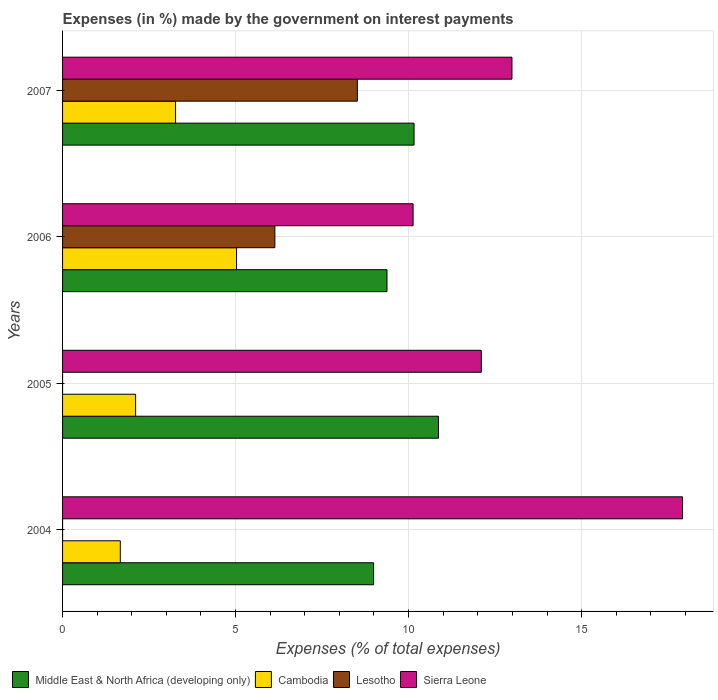How many different coloured bars are there?
Provide a short and direct response. 4. Are the number of bars per tick equal to the number of legend labels?
Provide a short and direct response. Yes. How many bars are there on the 4th tick from the top?
Provide a short and direct response. 4. How many bars are there on the 3rd tick from the bottom?
Your answer should be very brief. 4. In how many cases, is the number of bars for a given year not equal to the number of legend labels?
Keep it short and to the point. 0. What is the percentage of expenses made by the government on interest payments in Lesotho in 2007?
Make the answer very short. 8.52. Across all years, what is the maximum percentage of expenses made by the government on interest payments in Middle East & North Africa (developing only)?
Your answer should be compact. 10.86. Across all years, what is the minimum percentage of expenses made by the government on interest payments in Sierra Leone?
Your answer should be very brief. 10.13. In which year was the percentage of expenses made by the government on interest payments in Lesotho maximum?
Provide a short and direct response. 2007. What is the total percentage of expenses made by the government on interest payments in Sierra Leone in the graph?
Provide a short and direct response. 53.13. What is the difference between the percentage of expenses made by the government on interest payments in Middle East & North Africa (developing only) in 2004 and that in 2005?
Provide a succinct answer. -1.87. What is the difference between the percentage of expenses made by the government on interest payments in Lesotho in 2004 and the percentage of expenses made by the government on interest payments in Sierra Leone in 2006?
Make the answer very short. -10.13. What is the average percentage of expenses made by the government on interest payments in Sierra Leone per year?
Make the answer very short. 13.28. In the year 2006, what is the difference between the percentage of expenses made by the government on interest payments in Cambodia and percentage of expenses made by the government on interest payments in Middle East & North Africa (developing only)?
Your answer should be compact. -4.35. In how many years, is the percentage of expenses made by the government on interest payments in Lesotho greater than 14 %?
Make the answer very short. 0. What is the ratio of the percentage of expenses made by the government on interest payments in Cambodia in 2005 to that in 2006?
Your answer should be compact. 0.42. Is the difference between the percentage of expenses made by the government on interest payments in Cambodia in 2004 and 2005 greater than the difference between the percentage of expenses made by the government on interest payments in Middle East & North Africa (developing only) in 2004 and 2005?
Make the answer very short. Yes. What is the difference between the highest and the second highest percentage of expenses made by the government on interest payments in Cambodia?
Your answer should be compact. 1.76. What is the difference between the highest and the lowest percentage of expenses made by the government on interest payments in Sierra Leone?
Give a very brief answer. 7.79. In how many years, is the percentage of expenses made by the government on interest payments in Lesotho greater than the average percentage of expenses made by the government on interest payments in Lesotho taken over all years?
Your answer should be compact. 2. Is the sum of the percentage of expenses made by the government on interest payments in Sierra Leone in 2004 and 2007 greater than the maximum percentage of expenses made by the government on interest payments in Cambodia across all years?
Keep it short and to the point. Yes. Is it the case that in every year, the sum of the percentage of expenses made by the government on interest payments in Lesotho and percentage of expenses made by the government on interest payments in Sierra Leone is greater than the sum of percentage of expenses made by the government on interest payments in Cambodia and percentage of expenses made by the government on interest payments in Middle East & North Africa (developing only)?
Provide a short and direct response. No. What does the 3rd bar from the top in 2007 represents?
Your answer should be compact. Cambodia. What does the 1st bar from the bottom in 2007 represents?
Offer a terse response. Middle East & North Africa (developing only). Are all the bars in the graph horizontal?
Your response must be concise. Yes. What is the difference between two consecutive major ticks on the X-axis?
Make the answer very short. 5. Does the graph contain any zero values?
Keep it short and to the point. No. Does the graph contain grids?
Your answer should be compact. Yes. Where does the legend appear in the graph?
Ensure brevity in your answer.  Bottom left. How are the legend labels stacked?
Your answer should be compact. Horizontal. What is the title of the graph?
Ensure brevity in your answer.  Expenses (in %) made by the government on interest payments. What is the label or title of the X-axis?
Your answer should be compact. Expenses (% of total expenses). What is the Expenses (% of total expenses) of Middle East & North Africa (developing only) in 2004?
Your answer should be compact. 8.99. What is the Expenses (% of total expenses) in Cambodia in 2004?
Your answer should be very brief. 1.67. What is the Expenses (% of total expenses) of Lesotho in 2004?
Offer a very short reply. 2.999997087200831e-5. What is the Expenses (% of total expenses) of Sierra Leone in 2004?
Provide a short and direct response. 17.92. What is the Expenses (% of total expenses) in Middle East & North Africa (developing only) in 2005?
Provide a succinct answer. 10.86. What is the Expenses (% of total expenses) in Cambodia in 2005?
Offer a terse response. 2.11. What is the Expenses (% of total expenses) in Lesotho in 2005?
Your answer should be very brief. 0. What is the Expenses (% of total expenses) of Sierra Leone in 2005?
Offer a terse response. 12.1. What is the Expenses (% of total expenses) of Middle East & North Africa (developing only) in 2006?
Give a very brief answer. 9.38. What is the Expenses (% of total expenses) of Cambodia in 2006?
Your answer should be compact. 5.03. What is the Expenses (% of total expenses) of Lesotho in 2006?
Keep it short and to the point. 6.14. What is the Expenses (% of total expenses) of Sierra Leone in 2006?
Offer a terse response. 10.13. What is the Expenses (% of total expenses) in Middle East & North Africa (developing only) in 2007?
Your answer should be very brief. 10.16. What is the Expenses (% of total expenses) of Cambodia in 2007?
Keep it short and to the point. 3.27. What is the Expenses (% of total expenses) in Lesotho in 2007?
Provide a short and direct response. 8.52. What is the Expenses (% of total expenses) in Sierra Leone in 2007?
Offer a terse response. 12.99. Across all years, what is the maximum Expenses (% of total expenses) in Middle East & North Africa (developing only)?
Ensure brevity in your answer.  10.86. Across all years, what is the maximum Expenses (% of total expenses) in Cambodia?
Your answer should be compact. 5.03. Across all years, what is the maximum Expenses (% of total expenses) in Lesotho?
Ensure brevity in your answer.  8.52. Across all years, what is the maximum Expenses (% of total expenses) of Sierra Leone?
Provide a short and direct response. 17.92. Across all years, what is the minimum Expenses (% of total expenses) of Middle East & North Africa (developing only)?
Your answer should be compact. 8.99. Across all years, what is the minimum Expenses (% of total expenses) of Cambodia?
Ensure brevity in your answer.  1.67. Across all years, what is the minimum Expenses (% of total expenses) of Lesotho?
Provide a short and direct response. 2.999997087200831e-5. Across all years, what is the minimum Expenses (% of total expenses) of Sierra Leone?
Your answer should be very brief. 10.13. What is the total Expenses (% of total expenses) of Middle East & North Africa (developing only) in the graph?
Make the answer very short. 39.39. What is the total Expenses (% of total expenses) in Cambodia in the graph?
Provide a short and direct response. 12.08. What is the total Expenses (% of total expenses) in Lesotho in the graph?
Offer a very short reply. 14.65. What is the total Expenses (% of total expenses) of Sierra Leone in the graph?
Offer a terse response. 53.13. What is the difference between the Expenses (% of total expenses) of Middle East & North Africa (developing only) in 2004 and that in 2005?
Give a very brief answer. -1.87. What is the difference between the Expenses (% of total expenses) in Cambodia in 2004 and that in 2005?
Give a very brief answer. -0.44. What is the difference between the Expenses (% of total expenses) in Lesotho in 2004 and that in 2005?
Make the answer very short. -0. What is the difference between the Expenses (% of total expenses) of Sierra Leone in 2004 and that in 2005?
Offer a very short reply. 5.81. What is the difference between the Expenses (% of total expenses) in Middle East & North Africa (developing only) in 2004 and that in 2006?
Your answer should be compact. -0.39. What is the difference between the Expenses (% of total expenses) of Cambodia in 2004 and that in 2006?
Keep it short and to the point. -3.36. What is the difference between the Expenses (% of total expenses) of Lesotho in 2004 and that in 2006?
Offer a terse response. -6.14. What is the difference between the Expenses (% of total expenses) of Sierra Leone in 2004 and that in 2006?
Ensure brevity in your answer.  7.79. What is the difference between the Expenses (% of total expenses) of Middle East & North Africa (developing only) in 2004 and that in 2007?
Provide a succinct answer. -1.17. What is the difference between the Expenses (% of total expenses) in Cambodia in 2004 and that in 2007?
Offer a terse response. -1.6. What is the difference between the Expenses (% of total expenses) of Lesotho in 2004 and that in 2007?
Give a very brief answer. -8.52. What is the difference between the Expenses (% of total expenses) of Sierra Leone in 2004 and that in 2007?
Offer a very short reply. 4.93. What is the difference between the Expenses (% of total expenses) of Middle East & North Africa (developing only) in 2005 and that in 2006?
Offer a terse response. 1.49. What is the difference between the Expenses (% of total expenses) in Cambodia in 2005 and that in 2006?
Offer a very short reply. -2.92. What is the difference between the Expenses (% of total expenses) in Lesotho in 2005 and that in 2006?
Provide a succinct answer. -6.14. What is the difference between the Expenses (% of total expenses) of Sierra Leone in 2005 and that in 2006?
Ensure brevity in your answer.  1.97. What is the difference between the Expenses (% of total expenses) in Middle East & North Africa (developing only) in 2005 and that in 2007?
Your response must be concise. 0.71. What is the difference between the Expenses (% of total expenses) in Cambodia in 2005 and that in 2007?
Offer a terse response. -1.15. What is the difference between the Expenses (% of total expenses) in Lesotho in 2005 and that in 2007?
Keep it short and to the point. -8.52. What is the difference between the Expenses (% of total expenses) in Sierra Leone in 2005 and that in 2007?
Your answer should be very brief. -0.89. What is the difference between the Expenses (% of total expenses) of Middle East & North Africa (developing only) in 2006 and that in 2007?
Provide a succinct answer. -0.78. What is the difference between the Expenses (% of total expenses) of Cambodia in 2006 and that in 2007?
Ensure brevity in your answer.  1.76. What is the difference between the Expenses (% of total expenses) in Lesotho in 2006 and that in 2007?
Provide a short and direct response. -2.38. What is the difference between the Expenses (% of total expenses) of Sierra Leone in 2006 and that in 2007?
Your answer should be compact. -2.86. What is the difference between the Expenses (% of total expenses) of Middle East & North Africa (developing only) in 2004 and the Expenses (% of total expenses) of Cambodia in 2005?
Make the answer very short. 6.88. What is the difference between the Expenses (% of total expenses) in Middle East & North Africa (developing only) in 2004 and the Expenses (% of total expenses) in Lesotho in 2005?
Offer a very short reply. 8.99. What is the difference between the Expenses (% of total expenses) of Middle East & North Africa (developing only) in 2004 and the Expenses (% of total expenses) of Sierra Leone in 2005?
Offer a terse response. -3.11. What is the difference between the Expenses (% of total expenses) of Cambodia in 2004 and the Expenses (% of total expenses) of Lesotho in 2005?
Give a very brief answer. 1.67. What is the difference between the Expenses (% of total expenses) of Cambodia in 2004 and the Expenses (% of total expenses) of Sierra Leone in 2005?
Offer a very short reply. -10.43. What is the difference between the Expenses (% of total expenses) of Lesotho in 2004 and the Expenses (% of total expenses) of Sierra Leone in 2005?
Provide a short and direct response. -12.1. What is the difference between the Expenses (% of total expenses) in Middle East & North Africa (developing only) in 2004 and the Expenses (% of total expenses) in Cambodia in 2006?
Offer a very short reply. 3.96. What is the difference between the Expenses (% of total expenses) in Middle East & North Africa (developing only) in 2004 and the Expenses (% of total expenses) in Lesotho in 2006?
Provide a succinct answer. 2.85. What is the difference between the Expenses (% of total expenses) in Middle East & North Africa (developing only) in 2004 and the Expenses (% of total expenses) in Sierra Leone in 2006?
Offer a terse response. -1.14. What is the difference between the Expenses (% of total expenses) of Cambodia in 2004 and the Expenses (% of total expenses) of Lesotho in 2006?
Ensure brevity in your answer.  -4.47. What is the difference between the Expenses (% of total expenses) in Cambodia in 2004 and the Expenses (% of total expenses) in Sierra Leone in 2006?
Provide a succinct answer. -8.46. What is the difference between the Expenses (% of total expenses) in Lesotho in 2004 and the Expenses (% of total expenses) in Sierra Leone in 2006?
Your answer should be very brief. -10.13. What is the difference between the Expenses (% of total expenses) of Middle East & North Africa (developing only) in 2004 and the Expenses (% of total expenses) of Cambodia in 2007?
Provide a succinct answer. 5.72. What is the difference between the Expenses (% of total expenses) of Middle East & North Africa (developing only) in 2004 and the Expenses (% of total expenses) of Lesotho in 2007?
Offer a terse response. 0.47. What is the difference between the Expenses (% of total expenses) in Middle East & North Africa (developing only) in 2004 and the Expenses (% of total expenses) in Sierra Leone in 2007?
Your response must be concise. -4. What is the difference between the Expenses (% of total expenses) in Cambodia in 2004 and the Expenses (% of total expenses) in Lesotho in 2007?
Keep it short and to the point. -6.85. What is the difference between the Expenses (% of total expenses) of Cambodia in 2004 and the Expenses (% of total expenses) of Sierra Leone in 2007?
Provide a succinct answer. -11.32. What is the difference between the Expenses (% of total expenses) in Lesotho in 2004 and the Expenses (% of total expenses) in Sierra Leone in 2007?
Your answer should be compact. -12.99. What is the difference between the Expenses (% of total expenses) in Middle East & North Africa (developing only) in 2005 and the Expenses (% of total expenses) in Cambodia in 2006?
Make the answer very short. 5.84. What is the difference between the Expenses (% of total expenses) of Middle East & North Africa (developing only) in 2005 and the Expenses (% of total expenses) of Lesotho in 2006?
Ensure brevity in your answer.  4.73. What is the difference between the Expenses (% of total expenses) in Middle East & North Africa (developing only) in 2005 and the Expenses (% of total expenses) in Sierra Leone in 2006?
Your answer should be compact. 0.73. What is the difference between the Expenses (% of total expenses) of Cambodia in 2005 and the Expenses (% of total expenses) of Lesotho in 2006?
Keep it short and to the point. -4.02. What is the difference between the Expenses (% of total expenses) in Cambodia in 2005 and the Expenses (% of total expenses) in Sierra Leone in 2006?
Offer a very short reply. -8.02. What is the difference between the Expenses (% of total expenses) in Lesotho in 2005 and the Expenses (% of total expenses) in Sierra Leone in 2006?
Your answer should be compact. -10.13. What is the difference between the Expenses (% of total expenses) in Middle East & North Africa (developing only) in 2005 and the Expenses (% of total expenses) in Cambodia in 2007?
Offer a very short reply. 7.6. What is the difference between the Expenses (% of total expenses) in Middle East & North Africa (developing only) in 2005 and the Expenses (% of total expenses) in Lesotho in 2007?
Ensure brevity in your answer.  2.34. What is the difference between the Expenses (% of total expenses) in Middle East & North Africa (developing only) in 2005 and the Expenses (% of total expenses) in Sierra Leone in 2007?
Keep it short and to the point. -2.12. What is the difference between the Expenses (% of total expenses) in Cambodia in 2005 and the Expenses (% of total expenses) in Lesotho in 2007?
Your response must be concise. -6.41. What is the difference between the Expenses (% of total expenses) in Cambodia in 2005 and the Expenses (% of total expenses) in Sierra Leone in 2007?
Provide a short and direct response. -10.88. What is the difference between the Expenses (% of total expenses) of Lesotho in 2005 and the Expenses (% of total expenses) of Sierra Leone in 2007?
Offer a very short reply. -12.99. What is the difference between the Expenses (% of total expenses) in Middle East & North Africa (developing only) in 2006 and the Expenses (% of total expenses) in Cambodia in 2007?
Ensure brevity in your answer.  6.11. What is the difference between the Expenses (% of total expenses) of Middle East & North Africa (developing only) in 2006 and the Expenses (% of total expenses) of Lesotho in 2007?
Provide a succinct answer. 0.86. What is the difference between the Expenses (% of total expenses) of Middle East & North Africa (developing only) in 2006 and the Expenses (% of total expenses) of Sierra Leone in 2007?
Offer a very short reply. -3.61. What is the difference between the Expenses (% of total expenses) in Cambodia in 2006 and the Expenses (% of total expenses) in Lesotho in 2007?
Your response must be concise. -3.49. What is the difference between the Expenses (% of total expenses) of Cambodia in 2006 and the Expenses (% of total expenses) of Sierra Leone in 2007?
Your answer should be compact. -7.96. What is the difference between the Expenses (% of total expenses) of Lesotho in 2006 and the Expenses (% of total expenses) of Sierra Leone in 2007?
Make the answer very short. -6.85. What is the average Expenses (% of total expenses) in Middle East & North Africa (developing only) per year?
Your response must be concise. 9.85. What is the average Expenses (% of total expenses) in Cambodia per year?
Your response must be concise. 3.02. What is the average Expenses (% of total expenses) of Lesotho per year?
Provide a succinct answer. 3.66. What is the average Expenses (% of total expenses) in Sierra Leone per year?
Ensure brevity in your answer.  13.28. In the year 2004, what is the difference between the Expenses (% of total expenses) of Middle East & North Africa (developing only) and Expenses (% of total expenses) of Cambodia?
Your response must be concise. 7.32. In the year 2004, what is the difference between the Expenses (% of total expenses) in Middle East & North Africa (developing only) and Expenses (% of total expenses) in Lesotho?
Offer a terse response. 8.99. In the year 2004, what is the difference between the Expenses (% of total expenses) of Middle East & North Africa (developing only) and Expenses (% of total expenses) of Sierra Leone?
Your answer should be compact. -8.93. In the year 2004, what is the difference between the Expenses (% of total expenses) in Cambodia and Expenses (% of total expenses) in Lesotho?
Your answer should be very brief. 1.67. In the year 2004, what is the difference between the Expenses (% of total expenses) of Cambodia and Expenses (% of total expenses) of Sierra Leone?
Provide a succinct answer. -16.25. In the year 2004, what is the difference between the Expenses (% of total expenses) of Lesotho and Expenses (% of total expenses) of Sierra Leone?
Offer a terse response. -17.92. In the year 2005, what is the difference between the Expenses (% of total expenses) in Middle East & North Africa (developing only) and Expenses (% of total expenses) in Cambodia?
Offer a terse response. 8.75. In the year 2005, what is the difference between the Expenses (% of total expenses) in Middle East & North Africa (developing only) and Expenses (% of total expenses) in Lesotho?
Your answer should be compact. 10.86. In the year 2005, what is the difference between the Expenses (% of total expenses) of Middle East & North Africa (developing only) and Expenses (% of total expenses) of Sierra Leone?
Make the answer very short. -1.24. In the year 2005, what is the difference between the Expenses (% of total expenses) in Cambodia and Expenses (% of total expenses) in Lesotho?
Keep it short and to the point. 2.11. In the year 2005, what is the difference between the Expenses (% of total expenses) of Cambodia and Expenses (% of total expenses) of Sierra Leone?
Provide a succinct answer. -9.99. In the year 2005, what is the difference between the Expenses (% of total expenses) in Lesotho and Expenses (% of total expenses) in Sierra Leone?
Ensure brevity in your answer.  -12.1. In the year 2006, what is the difference between the Expenses (% of total expenses) of Middle East & North Africa (developing only) and Expenses (% of total expenses) of Cambodia?
Offer a terse response. 4.35. In the year 2006, what is the difference between the Expenses (% of total expenses) of Middle East & North Africa (developing only) and Expenses (% of total expenses) of Lesotho?
Provide a short and direct response. 3.24. In the year 2006, what is the difference between the Expenses (% of total expenses) in Middle East & North Africa (developing only) and Expenses (% of total expenses) in Sierra Leone?
Keep it short and to the point. -0.75. In the year 2006, what is the difference between the Expenses (% of total expenses) in Cambodia and Expenses (% of total expenses) in Lesotho?
Offer a very short reply. -1.11. In the year 2006, what is the difference between the Expenses (% of total expenses) of Cambodia and Expenses (% of total expenses) of Sierra Leone?
Make the answer very short. -5.1. In the year 2006, what is the difference between the Expenses (% of total expenses) of Lesotho and Expenses (% of total expenses) of Sierra Leone?
Provide a succinct answer. -3.99. In the year 2007, what is the difference between the Expenses (% of total expenses) in Middle East & North Africa (developing only) and Expenses (% of total expenses) in Cambodia?
Offer a very short reply. 6.89. In the year 2007, what is the difference between the Expenses (% of total expenses) of Middle East & North Africa (developing only) and Expenses (% of total expenses) of Lesotho?
Give a very brief answer. 1.64. In the year 2007, what is the difference between the Expenses (% of total expenses) in Middle East & North Africa (developing only) and Expenses (% of total expenses) in Sierra Leone?
Your response must be concise. -2.83. In the year 2007, what is the difference between the Expenses (% of total expenses) of Cambodia and Expenses (% of total expenses) of Lesotho?
Your answer should be compact. -5.25. In the year 2007, what is the difference between the Expenses (% of total expenses) of Cambodia and Expenses (% of total expenses) of Sierra Leone?
Offer a terse response. -9.72. In the year 2007, what is the difference between the Expenses (% of total expenses) in Lesotho and Expenses (% of total expenses) in Sierra Leone?
Provide a short and direct response. -4.47. What is the ratio of the Expenses (% of total expenses) in Middle East & North Africa (developing only) in 2004 to that in 2005?
Your answer should be compact. 0.83. What is the ratio of the Expenses (% of total expenses) of Cambodia in 2004 to that in 2005?
Provide a short and direct response. 0.79. What is the ratio of the Expenses (% of total expenses) of Lesotho in 2004 to that in 2005?
Your answer should be very brief. 0.3. What is the ratio of the Expenses (% of total expenses) of Sierra Leone in 2004 to that in 2005?
Your answer should be very brief. 1.48. What is the ratio of the Expenses (% of total expenses) of Middle East & North Africa (developing only) in 2004 to that in 2006?
Your response must be concise. 0.96. What is the ratio of the Expenses (% of total expenses) in Cambodia in 2004 to that in 2006?
Your answer should be compact. 0.33. What is the ratio of the Expenses (% of total expenses) in Lesotho in 2004 to that in 2006?
Give a very brief answer. 0. What is the ratio of the Expenses (% of total expenses) in Sierra Leone in 2004 to that in 2006?
Give a very brief answer. 1.77. What is the ratio of the Expenses (% of total expenses) in Middle East & North Africa (developing only) in 2004 to that in 2007?
Keep it short and to the point. 0.88. What is the ratio of the Expenses (% of total expenses) in Cambodia in 2004 to that in 2007?
Make the answer very short. 0.51. What is the ratio of the Expenses (% of total expenses) in Sierra Leone in 2004 to that in 2007?
Ensure brevity in your answer.  1.38. What is the ratio of the Expenses (% of total expenses) in Middle East & North Africa (developing only) in 2005 to that in 2006?
Make the answer very short. 1.16. What is the ratio of the Expenses (% of total expenses) of Cambodia in 2005 to that in 2006?
Make the answer very short. 0.42. What is the ratio of the Expenses (% of total expenses) of Lesotho in 2005 to that in 2006?
Give a very brief answer. 0. What is the ratio of the Expenses (% of total expenses) of Sierra Leone in 2005 to that in 2006?
Your answer should be very brief. 1.19. What is the ratio of the Expenses (% of total expenses) of Middle East & North Africa (developing only) in 2005 to that in 2007?
Offer a very short reply. 1.07. What is the ratio of the Expenses (% of total expenses) of Cambodia in 2005 to that in 2007?
Provide a succinct answer. 0.65. What is the ratio of the Expenses (% of total expenses) in Sierra Leone in 2005 to that in 2007?
Keep it short and to the point. 0.93. What is the ratio of the Expenses (% of total expenses) in Middle East & North Africa (developing only) in 2006 to that in 2007?
Provide a succinct answer. 0.92. What is the ratio of the Expenses (% of total expenses) in Cambodia in 2006 to that in 2007?
Your answer should be very brief. 1.54. What is the ratio of the Expenses (% of total expenses) in Lesotho in 2006 to that in 2007?
Provide a short and direct response. 0.72. What is the ratio of the Expenses (% of total expenses) of Sierra Leone in 2006 to that in 2007?
Your response must be concise. 0.78. What is the difference between the highest and the second highest Expenses (% of total expenses) in Middle East & North Africa (developing only)?
Keep it short and to the point. 0.71. What is the difference between the highest and the second highest Expenses (% of total expenses) of Cambodia?
Make the answer very short. 1.76. What is the difference between the highest and the second highest Expenses (% of total expenses) of Lesotho?
Your answer should be compact. 2.38. What is the difference between the highest and the second highest Expenses (% of total expenses) of Sierra Leone?
Your response must be concise. 4.93. What is the difference between the highest and the lowest Expenses (% of total expenses) in Middle East & North Africa (developing only)?
Provide a short and direct response. 1.87. What is the difference between the highest and the lowest Expenses (% of total expenses) in Cambodia?
Give a very brief answer. 3.36. What is the difference between the highest and the lowest Expenses (% of total expenses) of Lesotho?
Offer a terse response. 8.52. What is the difference between the highest and the lowest Expenses (% of total expenses) of Sierra Leone?
Your response must be concise. 7.79. 